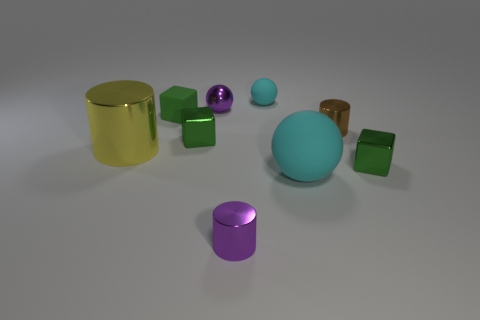Subtract all green blocks. How many were subtracted if there are1green blocks left? 2 Subtract all large shiny cylinders. How many cylinders are left? 2 Subtract all red cubes. How many cyan balls are left? 2 Subtract all cylinders. How many objects are left? 6 Add 2 purple balls. How many purple balls are left? 3 Add 9 blue blocks. How many blue blocks exist? 9 Subtract all brown cylinders. How many cylinders are left? 2 Subtract 1 brown cylinders. How many objects are left? 8 Subtract all purple cylinders. Subtract all gray balls. How many cylinders are left? 2 Subtract all large things. Subtract all large cyan spheres. How many objects are left? 6 